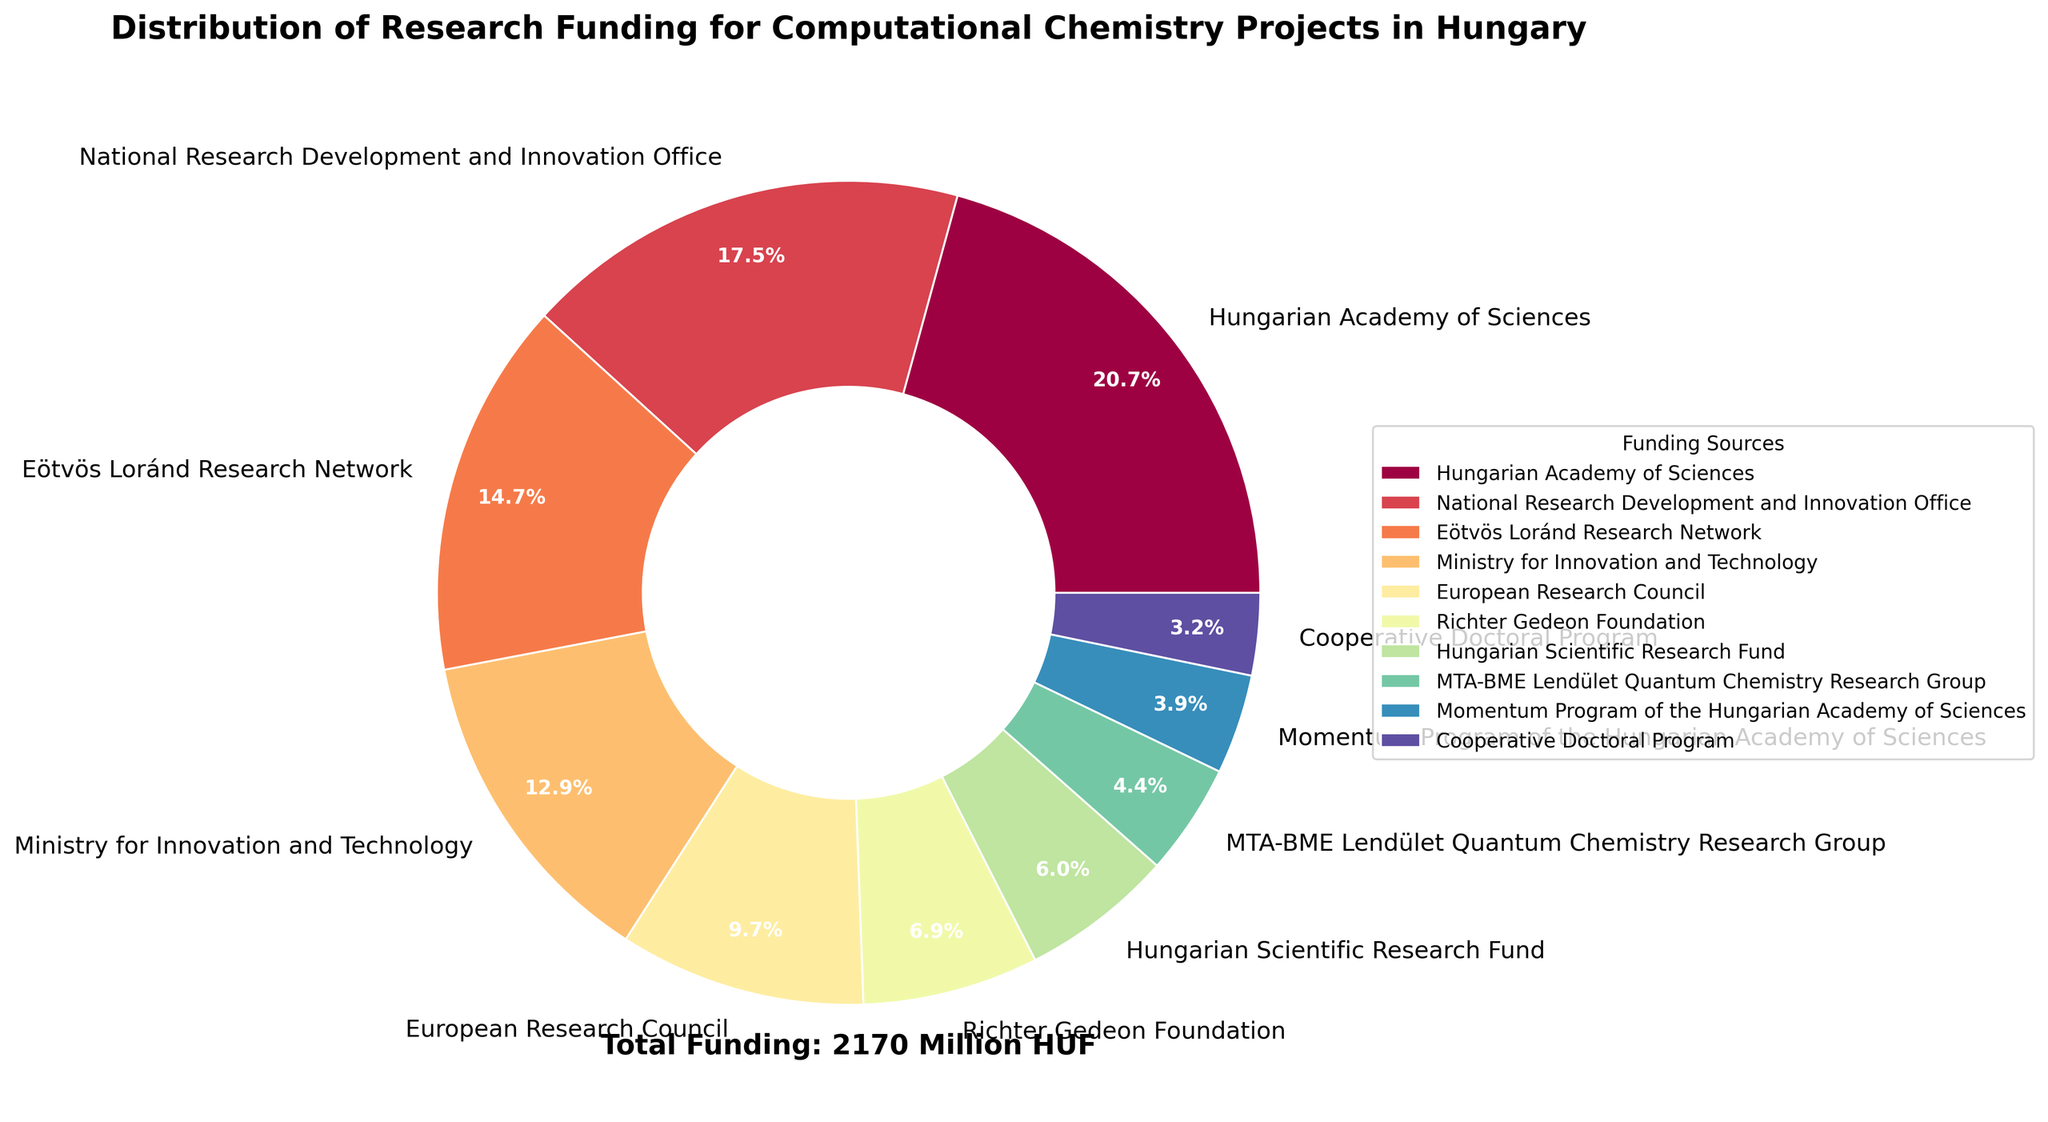What is the largest source of research funding for computational chemistry projects in Hungary? The pie chart shows different funding sources with the Hungarian Academy of Sciences having the largest segment. By comparing the size of the segments, it is clear that the Hungarian Academy of Sciences provides the most funding.
Answer: Hungarian Academy of Sciences Which funding source provides more support: the Ministry for Innovation and Technology or the Eötvös Loránd Research Network? The pie chart's segments for each funding source indicate their respective contributions. By comparing the sizes, it's evident that the Eötvös Loránd Research Network provides more funding.
Answer: Eötvös Loránd Research Network What is the combined funding amount from the National Research Development and Innovation Office and the European Research Council? The National Research Development and Innovation Office contributes 380 million HUF and the European Research Council contributes 210 million HUF. Their combined funding is 380 + 210 = 590 million HUF.
Answer: 590 million HUF Is the funding from the Momentum Program of the Hungarian Academy of Sciences greater than that of the Cooperative Doctoral Program? By comparing the segments for both the Momentum Program of the Hungarian Academy of Sciences and the Cooperative Doctoral Program, the former provides 85 million HUF, while the latter provides 70 million HUF. Therefore, the Momentum Program provides more funding.
Answer: Yes What is the total amount of research funding covered in the pie chart? The pie chart includes a text annotation indicating the total funding amount, which sums up all individual contributions. This value is directly mentioned as 2170 million HUF.
Answer: 2170 million HUF What percentage of the total funding is provided by Richter Gedeon Foundation? The Richter Gedeon Foundation contributes 150 million HUF. The total funding is 2170 million HUF. The percentage is calculated by (150 / 2170) * 100 ≈ 6.9%.
Answer: 6.9% How does the funding from the Hungarian Scientific Research Fund compare to the funding from MTA-BME Lendület Quantum Chemistry Research Group? Comparing both segments, the Hungarian Scientific Research Fund contributes 130 million HUF, and MTA-BME Lendület Quantum Chemistry Research Group contributes 95 million HUF. Thus, the former provides more funding.
Answer: Hungarian Scientific Research Fund What is the combined percentage contribution of the Hungarian Academy of Sciences and National Research Development and Innovation Office? The Hungarian Academy of Sciences provides 450 million HUF, and the National Research Development and Innovation Office provides 380 million HUF. Together, their contribution is 450 + 380 = 830 million HUF. The total funding is 2170 million HUF, so the percentage is (830 / 2170) * 100 ≈ 38.2%.
Answer: 38.2% Which funding source has the smallest contribution, and what is its amount? By observing the segments, the Cooperative Doctoral Program has the smallest segment, contributing 70 million HUF.
Answer: Cooperative Doctoral Program, 70 million HUF What is the difference in funding between the Eötvös Loránd Research Network and the Ministry for Innovation and Technology? The Eötvös Loránd Research Network provides 320 million HUF, while the Ministry for Innovation and Technology provides 280 million HUF. The difference is 320 - 280 = 40 million HUF.
Answer: 40 million HUF 